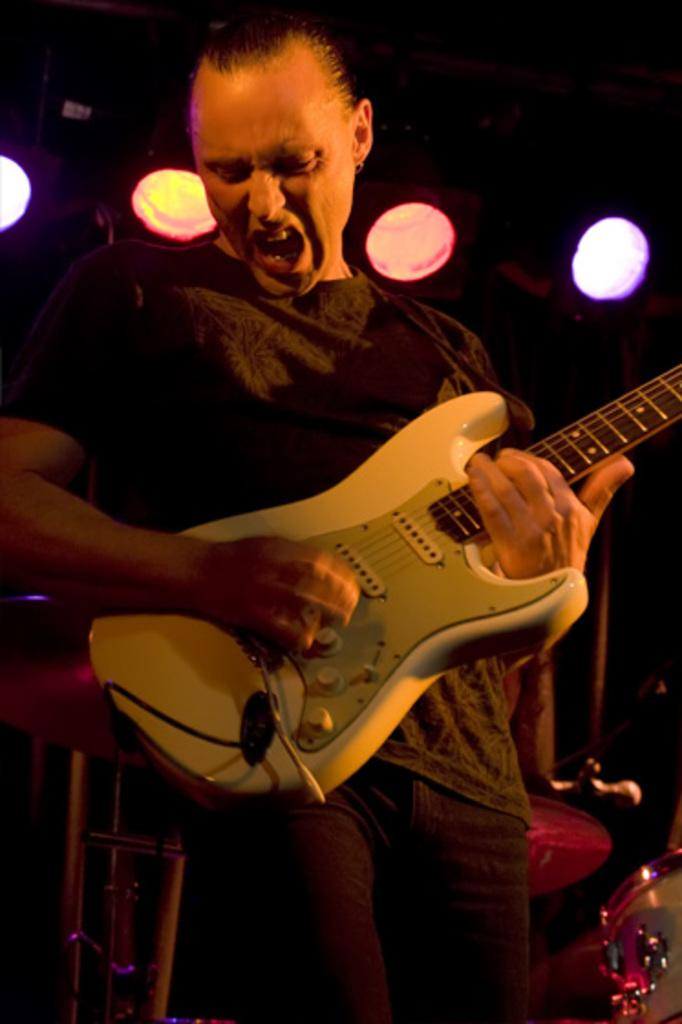What is the man in the image doing? The man is holding a guitar and singing. What is the man wearing in the image? The man is wearing a black t-shirt. What is the context of the scene in the image? The scene appears to be a singing contest. Where can the crayon be found in the image? There is no crayon present in the image. What type of medical treatment is the man receiving in the image? The image does not depict any medical treatment or hospital setting; it shows a man singing with a guitar. 